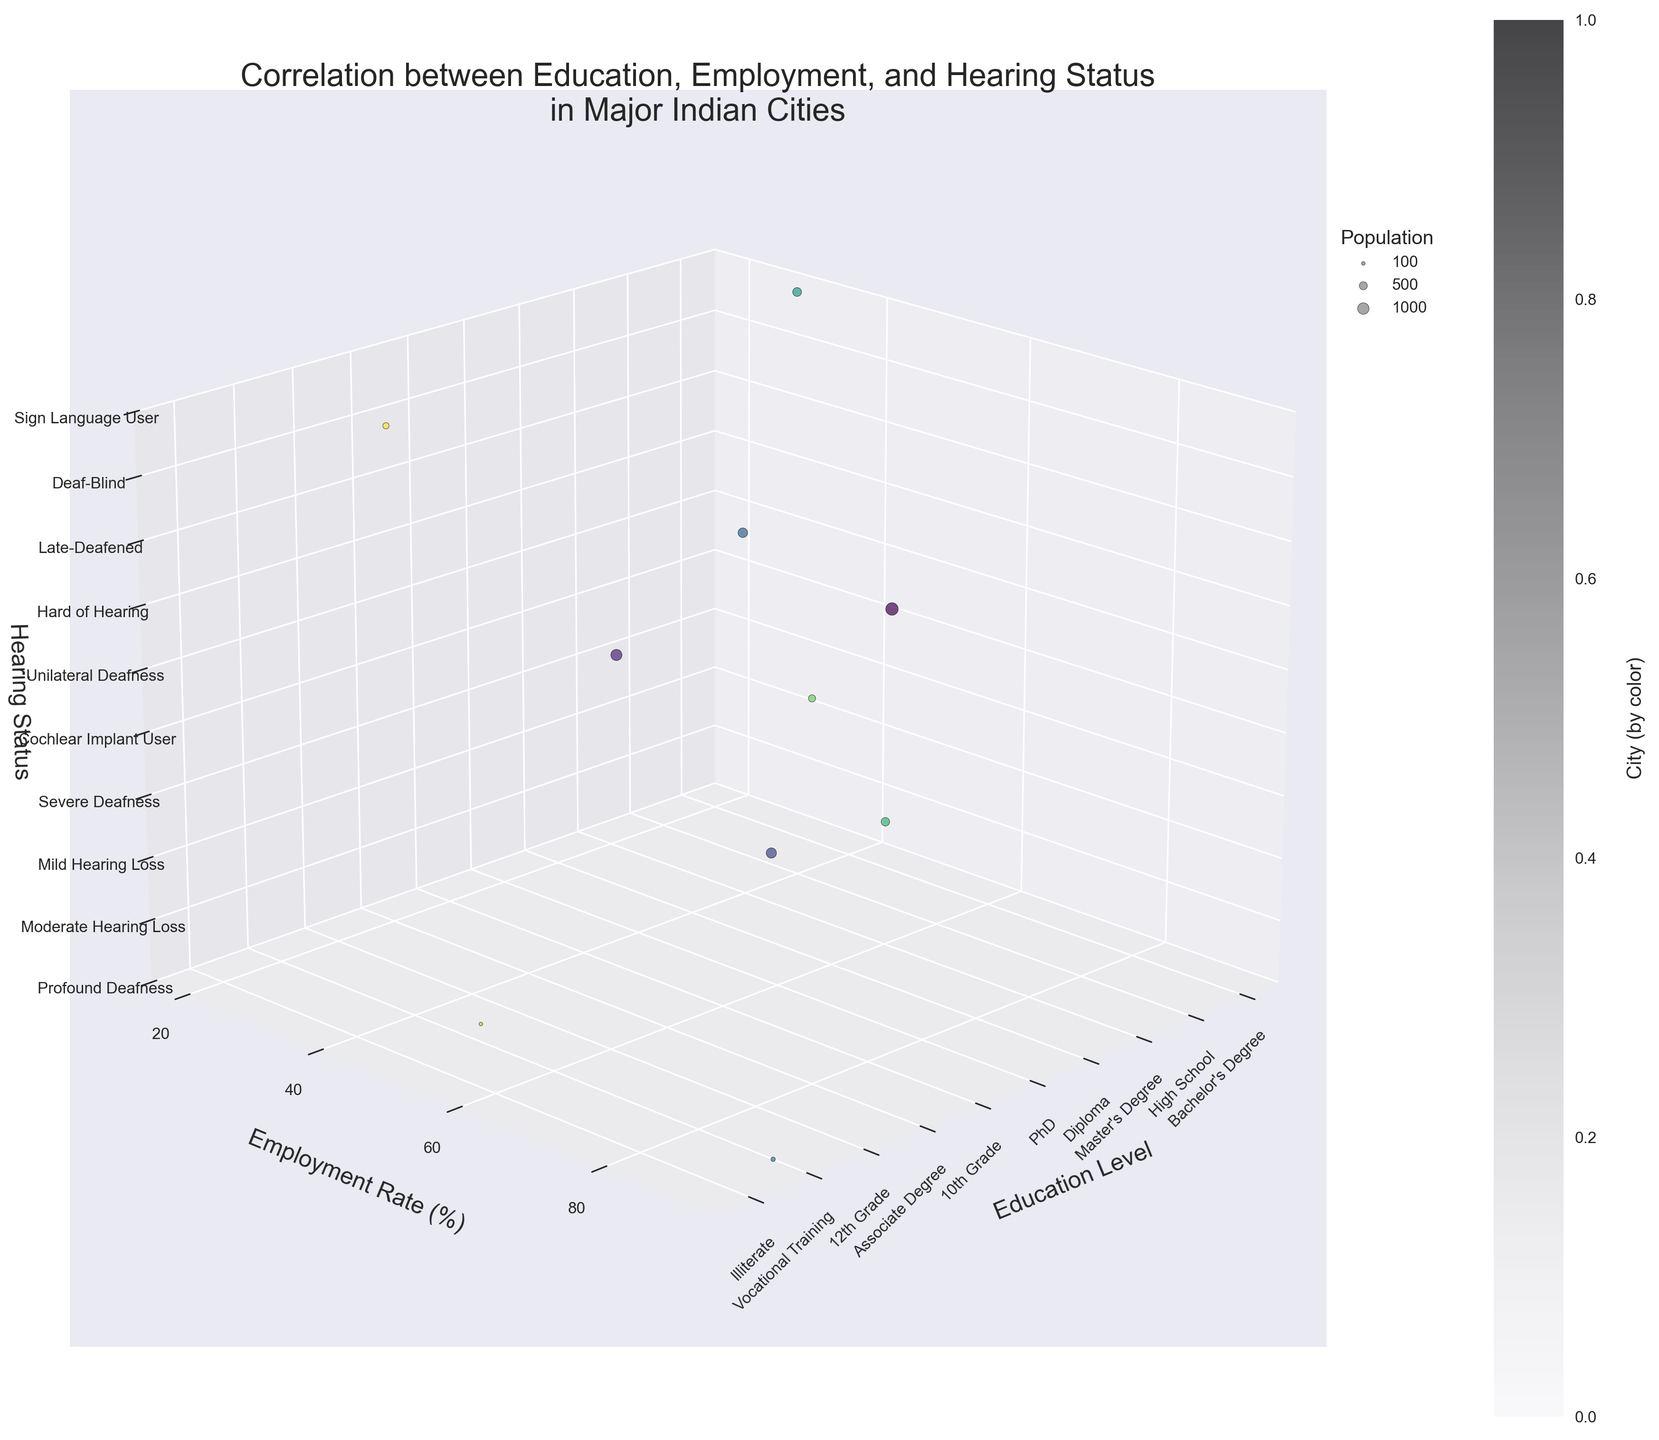What is the title of the figure? Look at the top of the figure where the title is usually placed.
Answer: Correlation between Education, Employment, and Hearing Status in Major Indian Cities How many unique cities are represented in the plot? Count the number of distinct colors representing different cities in the figure.
Answer: 10 Which city has the highest employment rate and what is that rate? Identify the city with the highest point on the y-axis, and read the accompanying label.
Answer: Kolkata, 90 What education level corresponds to an employment rate of 68%, and which city is it? Locate the point on the graph where the y-axis is 68 and identify its x-axis value and city color.
Answer: Bachelor's Degree, Mumbai Compare the employment rates between Delhi and Pune. Which city has a higher rate? Find the points representing Delhi and Pune along the y-axis and compare their heights.
Answer: Pune What's the difference in employment rate between the city with the highest education level and the lowest? Identify the cities corresponding to PhD and Illiterate along the x-axis, then find the difference in their y-axis values (employment rates).
Answer: 90 - 20 = 70 Identify the city with the largest population. What is the employment rate for this city? The largest bubble size represents the largest population. Find the corresponding y-axis value for this point.
Answer: Mumbai, 68 Which hearing status category has the most cities in its group? Count the number of points aligned with each value on the z-axis, corresponding to each hearing status.
Answer: Tied between various categories; each has one city What is the average employment rate for cities with Diploma and Associate Degree? Locate the employment rates for Chennai (Diploma) and Pune (Associate Degree) on the y-axis, then calculate the average. (55 + 60)/2 = 57.5
Answer: 57.5 Which city has the highest employment rate among those using sign language, and what is the rate? Identify the point with the specified hearing status on the z-axis, then read the corresponding y-axis value for employment rate.
Answer: Lucknow, 20 